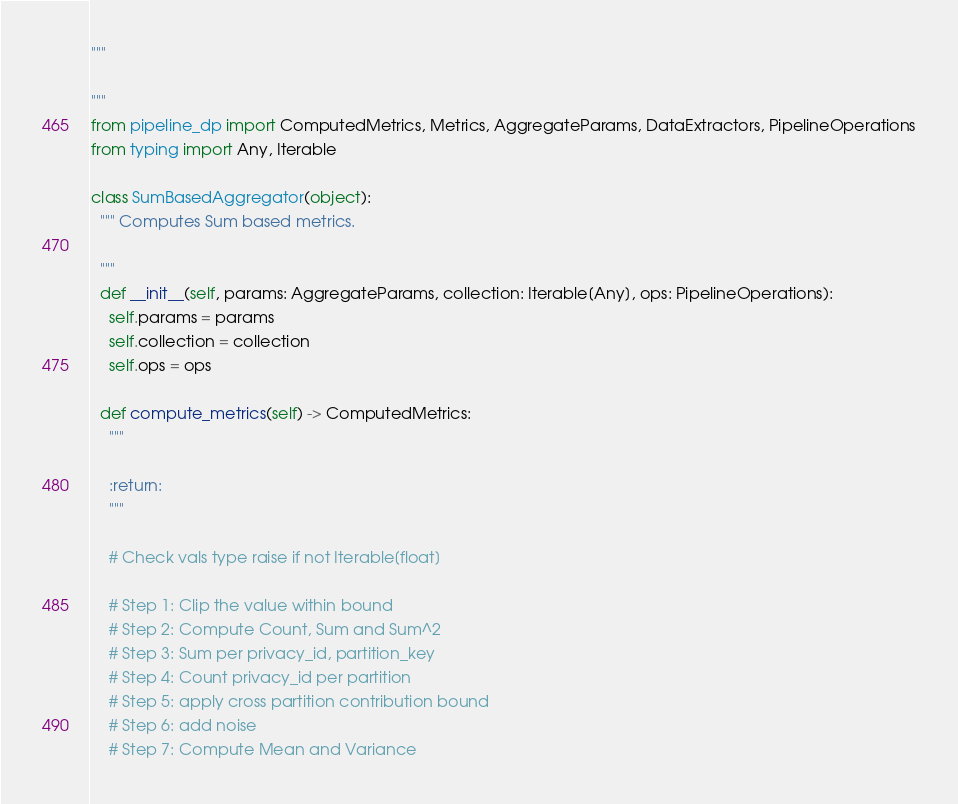<code> <loc_0><loc_0><loc_500><loc_500><_Python_>"""

"""
from pipeline_dp import ComputedMetrics, Metrics, AggregateParams, DataExtractors, PipelineOperations
from typing import Any, Iterable

class SumBasedAggregator(object):
  """ Computes Sum based metrics.

  """
  def __init__(self, params: AggregateParams, collection: Iterable[Any], ops: PipelineOperations):
    self.params = params
    self.collection = collection
    self.ops = ops

  def compute_metrics(self) -> ComputedMetrics:
    """
    
    :return:
    """

    # Check vals type raise if not Iterable[float]

    # Step 1: Clip the value within bound
    # Step 2: Compute Count, Sum and Sum^2
    # Step 3: Sum per privacy_id, partition_key
    # Step 4: Count privacy_id per partition
    # Step 5: apply cross partition contribution bound
    # Step 6: add noise
    # Step 7: Compute Mean and Variance


</code> 